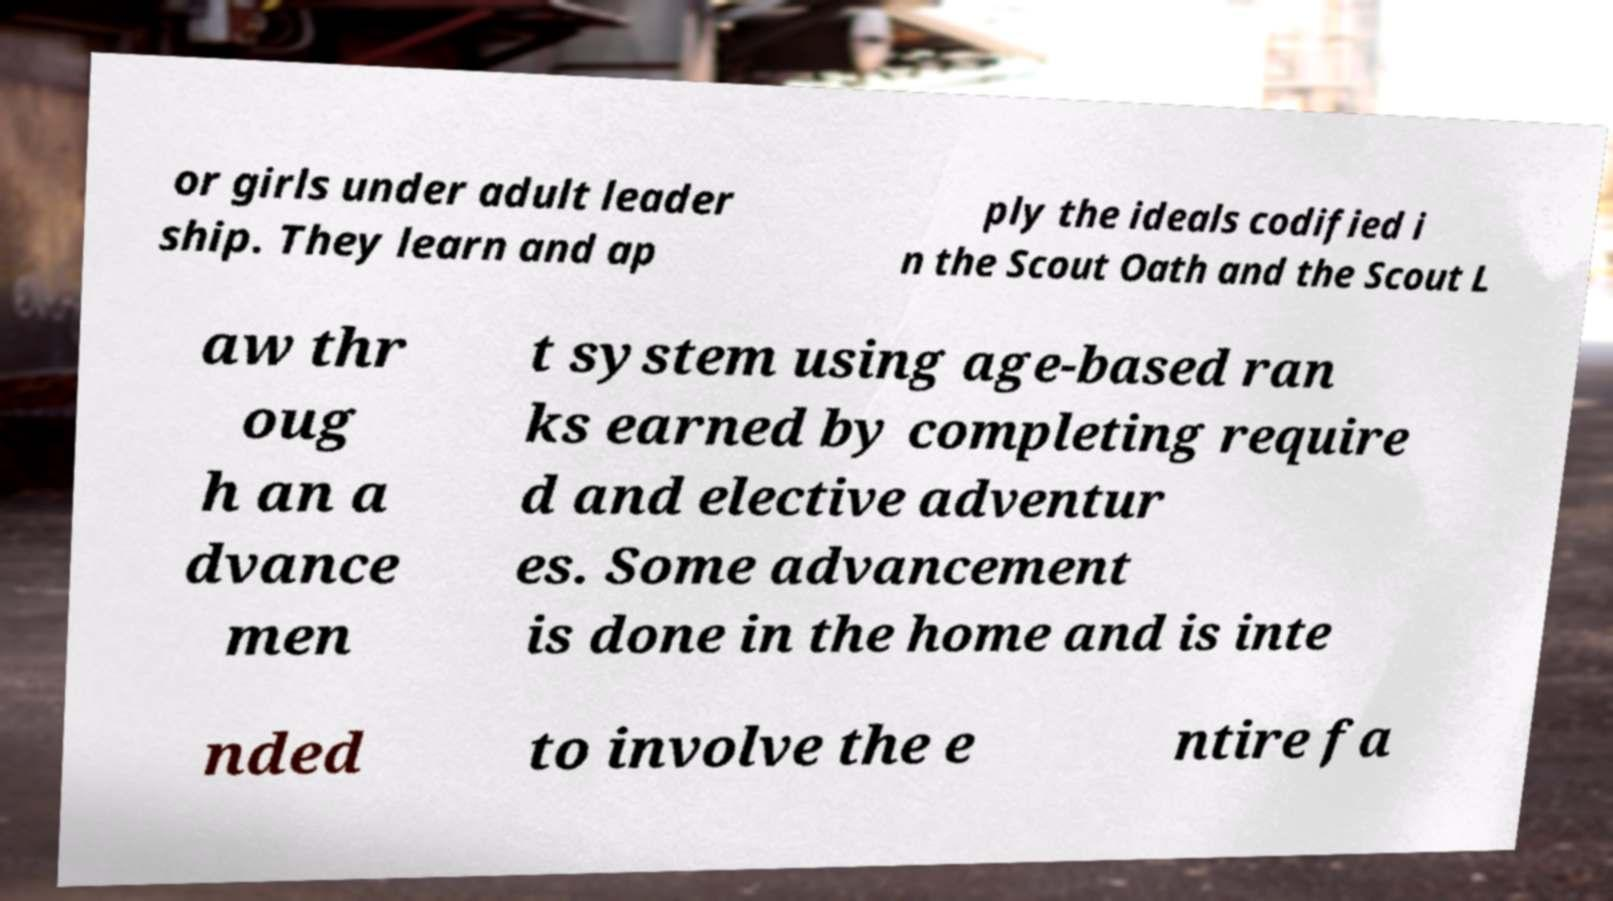Please read and relay the text visible in this image. What does it say? or girls under adult leader ship. They learn and ap ply the ideals codified i n the Scout Oath and the Scout L aw thr oug h an a dvance men t system using age-based ran ks earned by completing require d and elective adventur es. Some advancement is done in the home and is inte nded to involve the e ntire fa 